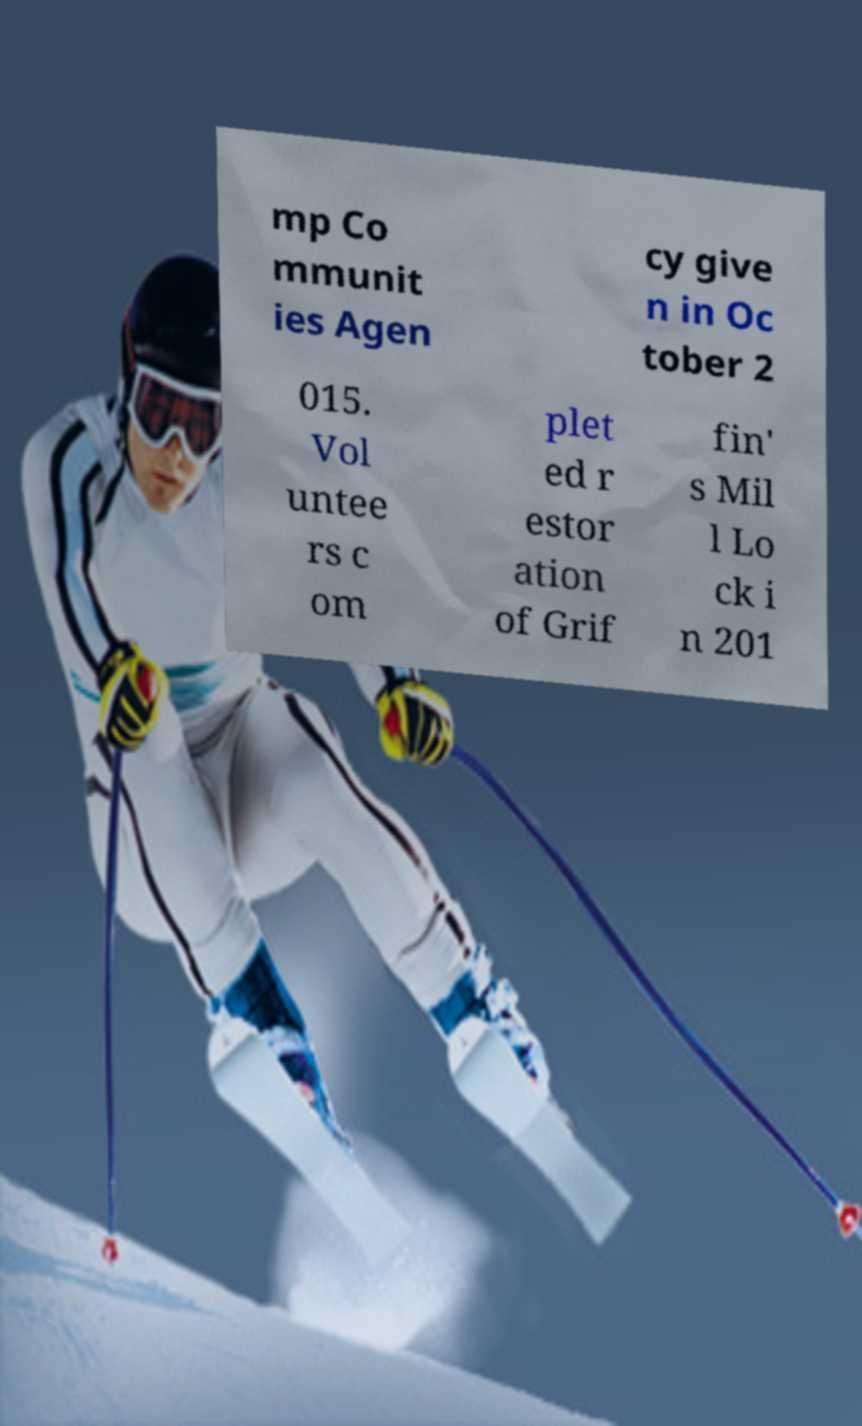Can you read and provide the text displayed in the image?This photo seems to have some interesting text. Can you extract and type it out for me? mp Co mmunit ies Agen cy give n in Oc tober 2 015. Vol untee rs c om plet ed r estor ation of Grif fin' s Mil l Lo ck i n 201 